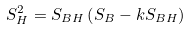Convert formula to latex. <formula><loc_0><loc_0><loc_500><loc_500>S _ { H } ^ { 2 } = S _ { B H } \left ( S _ { B } - k S _ { B H } \right )</formula> 